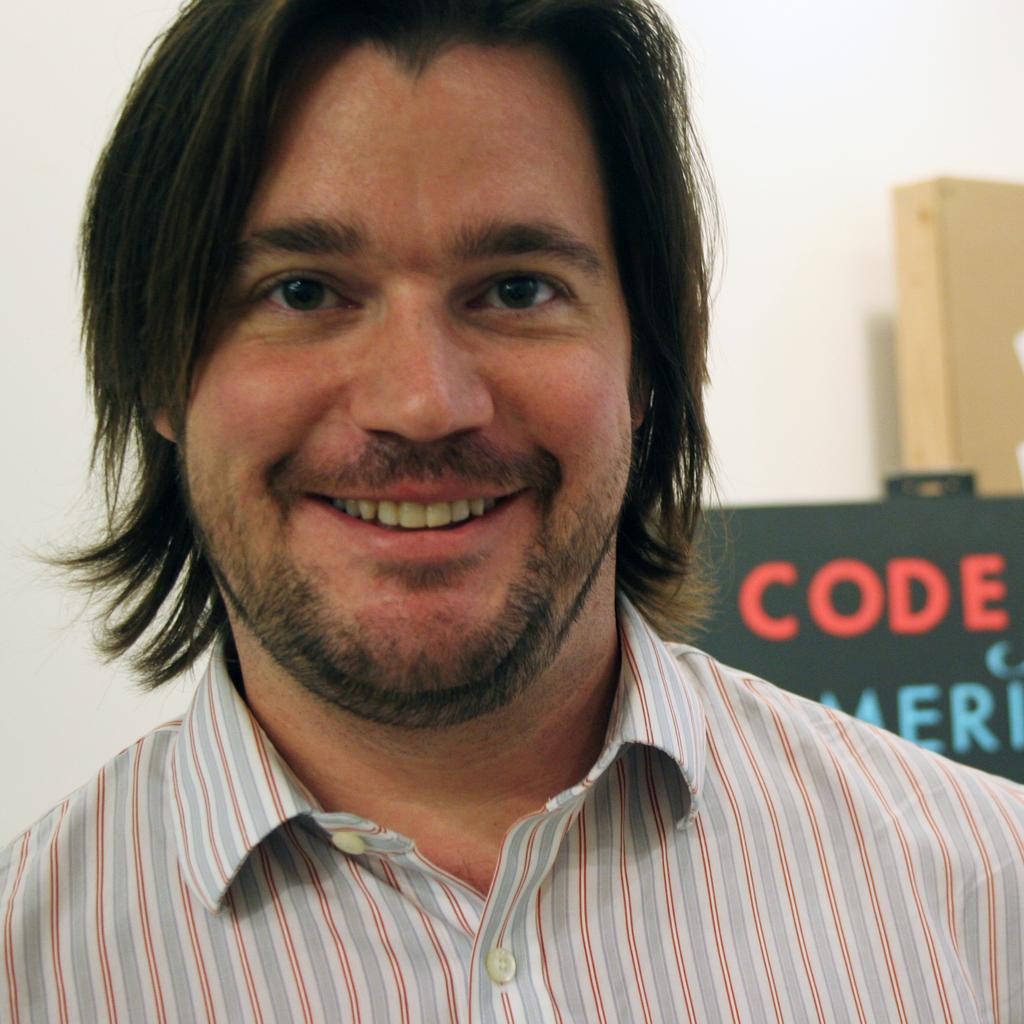Who or what is present in the image? There is a person in the image. Can you describe the person's attire? The person is wearing clothes. What can be seen on the right side of the image? There is a board on the right side of the image. What type of bone is visible in the image? There is no bone present in the image. What country is the person from in the image? The facts provided do not give any information about the person's country of origin, so we cannot determine their country from the image. 